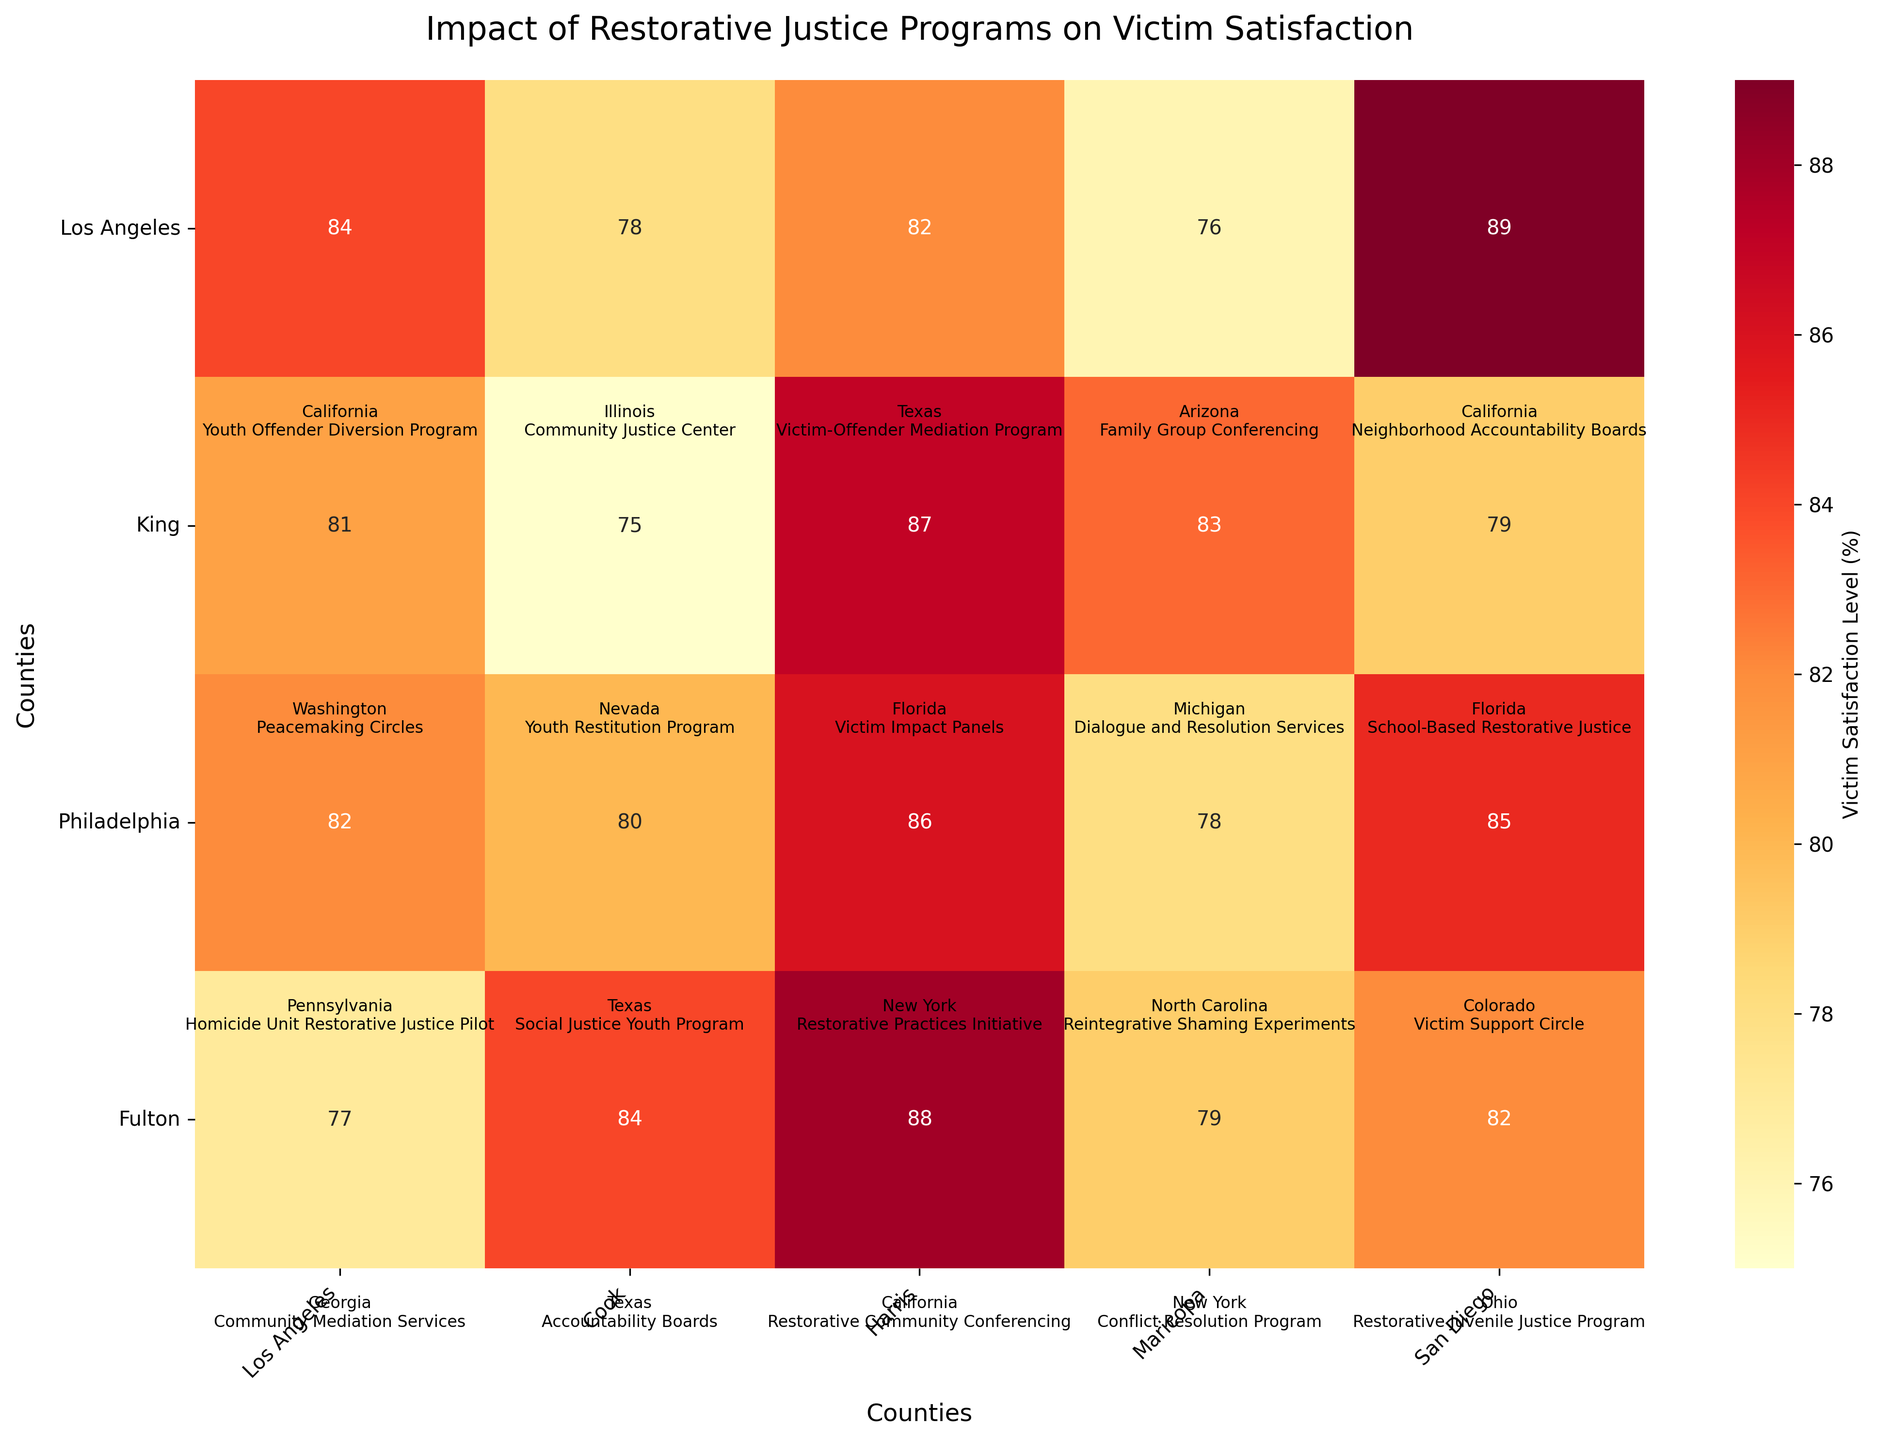What's the title of the heatmap? The title of the heatmap is the text displayed at the top, which provides a brief description of the contents.
Answer: Impact of Restorative Justice Programs on Victim Satisfaction How many counties are represented on the heatmap? By counting the tick labels on the x-axis and y-axis, and ensuring there are no repeats due to the heatmap structure, we see that the figure represents 20 counties.
Answer: 20 Which county has the highest victim satisfaction level? Look for the cell with the highest value. The highest value displayed in the annotated cells is 89.
Answer: San Diego, California Which county shows the lowest victim satisfaction level? Look for the cell with the lowest value. The lowest value shown in the heatmap is 75.
Answer: Clark, Nevada What is the average victim satisfaction level for counties in Texas? Identify the satisfaction levels for Harris (82), Dallas (80), and Bexar (84). Sum these values (82 + 80 + 84 = 246) and divide by the number of counties (246 / 3).
Answer: 82 Which state appears the most frequently on the heatmap? Identify and count the occurrences of each state listed in the labels. California is mentioned three times.
Answer: California What is the difference in victim satisfaction levels between the highest and lowest counties? Subtract the lowest satisfaction level (75 for Clark) from the highest satisfaction level (89 for San Diego).
Answer: 14 Which county has a restorative justice program named "Dialogue and Resolution Services"? Find the county with the corresponding program name in the heatmap’s text annotations.
Answer: Wayne, Michigan How many counties have a victim satisfaction level of 82%? Count the cells that have the annotated value of 82%.
Answer: 4 What is the median victim satisfaction level across all counties? List all satisfaction levels, sort them, and find the middle value in the ordered list (75, 76, 77, 78, 78, 79, 79, 80, 81, 82, 82, 82, 82, 83, 84, 84, 85, 86, 87, 88, 89). There are 20 values, so the median is the average of the 10th and 11th values (82 + 82) / 2.
Answer: 82 